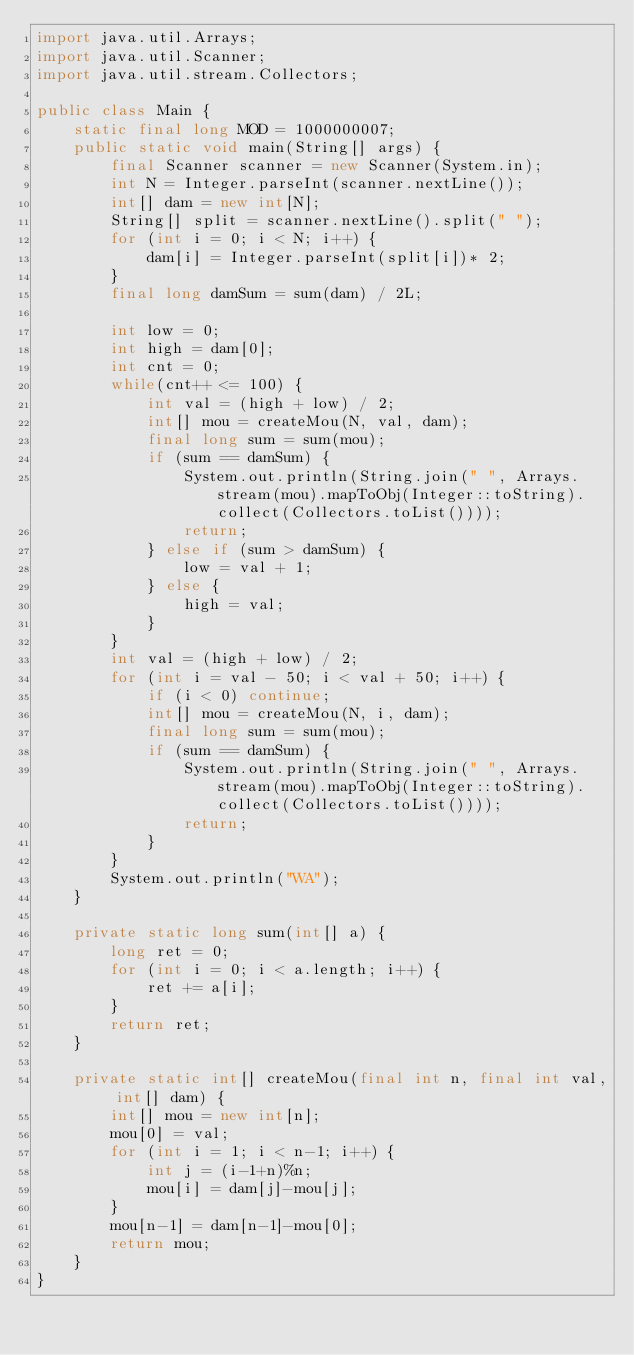<code> <loc_0><loc_0><loc_500><loc_500><_Java_>import java.util.Arrays;
import java.util.Scanner;
import java.util.stream.Collectors;

public class Main {
    static final long MOD = 1000000007;
    public static void main(String[] args) {
        final Scanner scanner = new Scanner(System.in);
        int N = Integer.parseInt(scanner.nextLine());
        int[] dam = new int[N];
        String[] split = scanner.nextLine().split(" ");
        for (int i = 0; i < N; i++) {
            dam[i] = Integer.parseInt(split[i])* 2;
        }
        final long damSum = sum(dam) / 2L;

        int low = 0;
        int high = dam[0];
        int cnt = 0;
        while(cnt++ <= 100) {
            int val = (high + low) / 2;
            int[] mou = createMou(N, val, dam);
            final long sum = sum(mou);
            if (sum == damSum) {
                System.out.println(String.join(" ", Arrays.stream(mou).mapToObj(Integer::toString).collect(Collectors.toList())));
                return;
            } else if (sum > damSum) {
                low = val + 1;
            } else {
                high = val;
            }
        }
        int val = (high + low) / 2;
        for (int i = val - 50; i < val + 50; i++) {
            if (i < 0) continue;
            int[] mou = createMou(N, i, dam);
            final long sum = sum(mou);
            if (sum == damSum) {
                System.out.println(String.join(" ", Arrays.stream(mou).mapToObj(Integer::toString).collect(Collectors.toList())));
                return;
            }
        }
        System.out.println("WA");
    }

    private static long sum(int[] a) {
        long ret = 0;
        for (int i = 0; i < a.length; i++) {
            ret += a[i];
        }
        return ret;
    }

    private static int[] createMou(final int n, final int val, int[] dam) {
        int[] mou = new int[n];
        mou[0] = val;
        for (int i = 1; i < n-1; i++) {
            int j = (i-1+n)%n;
            mou[i] = dam[j]-mou[j];
        }
        mou[n-1] = dam[n-1]-mou[0];
        return mou;
    }
}
</code> 